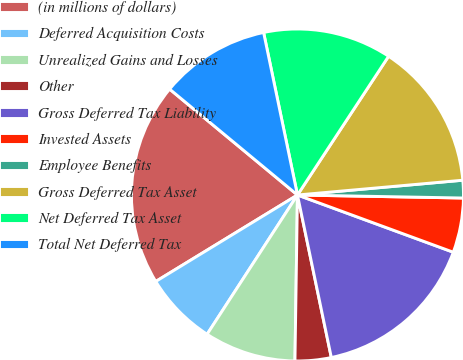Convert chart. <chart><loc_0><loc_0><loc_500><loc_500><pie_chart><fcel>(in millions of dollars)<fcel>Deferred Acquisition Costs<fcel>Unrealized Gains and Losses<fcel>Other<fcel>Gross Deferred Tax Liability<fcel>Invested Assets<fcel>Employee Benefits<fcel>Gross Deferred Tax Asset<fcel>Net Deferred Tax Asset<fcel>Total Net Deferred Tax<nl><fcel>19.73%<fcel>7.12%<fcel>8.92%<fcel>3.51%<fcel>16.13%<fcel>5.31%<fcel>1.71%<fcel>14.33%<fcel>12.52%<fcel>10.72%<nl></chart> 